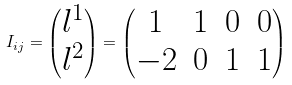Convert formula to latex. <formula><loc_0><loc_0><loc_500><loc_500>I _ { i j } = \begin{pmatrix} l ^ { 1 } \\ l ^ { 2 } \end{pmatrix} = \begin{pmatrix} 1 & 1 & 0 & 0 \\ - 2 & 0 & 1 & 1 \end{pmatrix}</formula> 